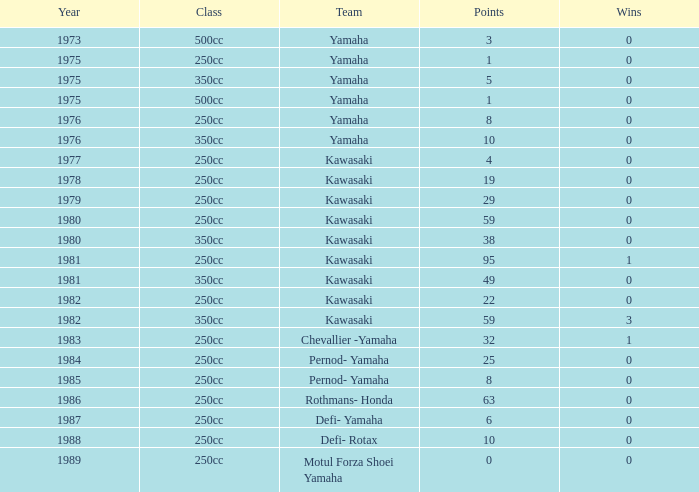Parse the full table. {'header': ['Year', 'Class', 'Team', 'Points', 'Wins'], 'rows': [['1973', '500cc', 'Yamaha', '3', '0'], ['1975', '250cc', 'Yamaha', '1', '0'], ['1975', '350cc', 'Yamaha', '5', '0'], ['1975', '500cc', 'Yamaha', '1', '0'], ['1976', '250cc', 'Yamaha', '8', '0'], ['1976', '350cc', 'Yamaha', '10', '0'], ['1977', '250cc', 'Kawasaki', '4', '0'], ['1978', '250cc', 'Kawasaki', '19', '0'], ['1979', '250cc', 'Kawasaki', '29', '0'], ['1980', '250cc', 'Kawasaki', '59', '0'], ['1980', '350cc', 'Kawasaki', '38', '0'], ['1981', '250cc', 'Kawasaki', '95', '1'], ['1981', '350cc', 'Kawasaki', '49', '0'], ['1982', '250cc', 'Kawasaki', '22', '0'], ['1982', '350cc', 'Kawasaki', '59', '3'], ['1983', '250cc', 'Chevallier -Yamaha', '32', '1'], ['1984', '250cc', 'Pernod- Yamaha', '25', '0'], ['1985', '250cc', 'Pernod- Yamaha', '8', '0'], ['1986', '250cc', 'Rothmans- Honda', '63', '0'], ['1987', '250cc', 'Defi- Yamaha', '6', '0'], ['1988', '250cc', 'Defi- Rotax', '10', '0'], ['1989', '250cc', 'Motul Forza Shoei Yamaha', '0', '0']]} Which highest wins number had Kawasaki as a team, 95 points, and a year prior to 1981? None. 